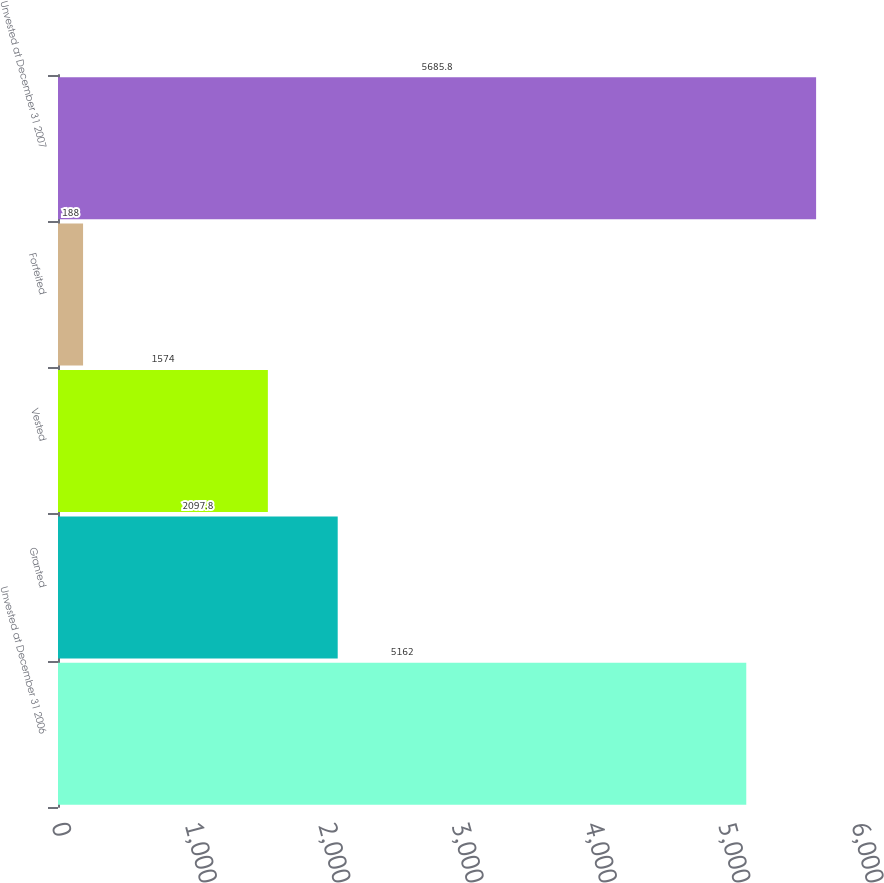<chart> <loc_0><loc_0><loc_500><loc_500><bar_chart><fcel>Unvested at December 31 2006<fcel>Granted<fcel>Vested<fcel>Forfeited<fcel>Unvested at December 31 2007<nl><fcel>5162<fcel>2097.8<fcel>1574<fcel>188<fcel>5685.8<nl></chart> 